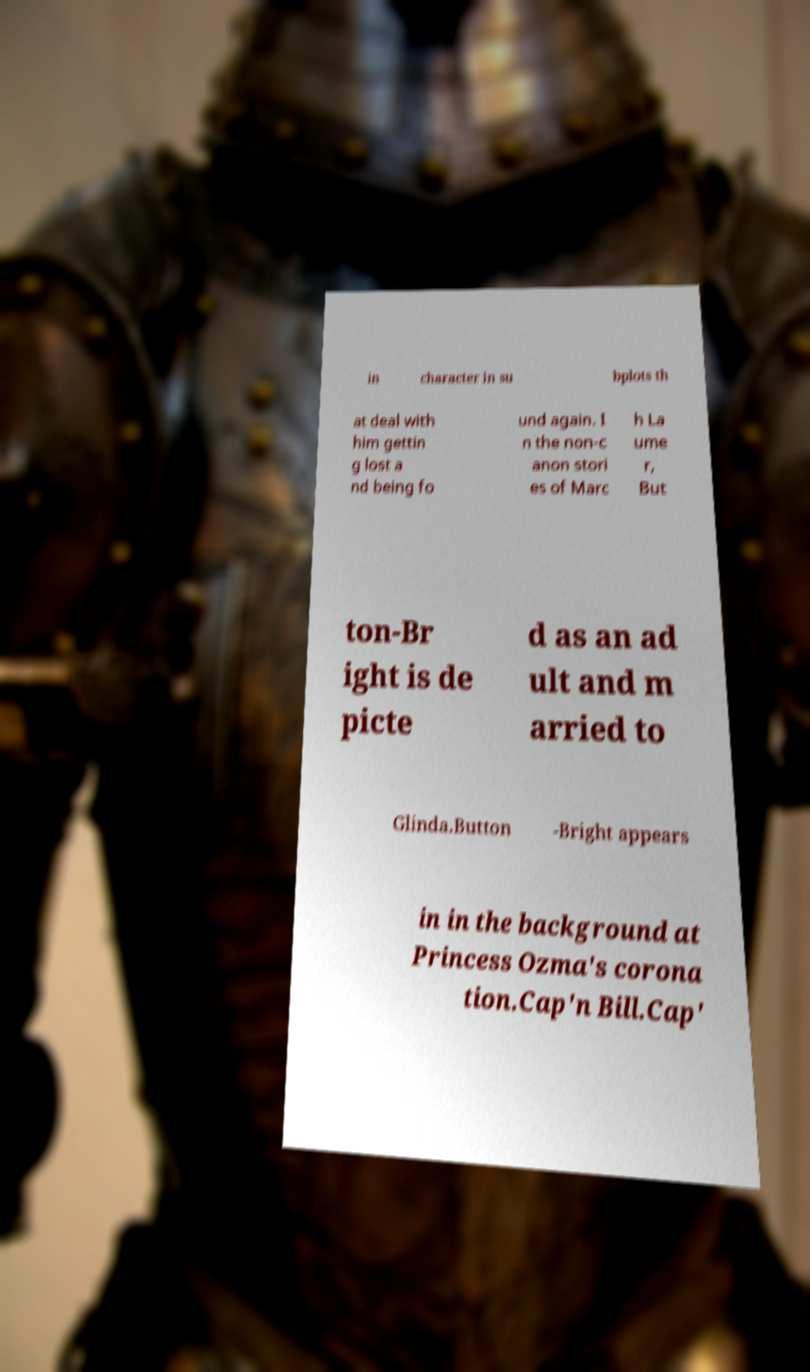For documentation purposes, I need the text within this image transcribed. Could you provide that? in character in su bplots th at deal with him gettin g lost a nd being fo und again. I n the non-c anon stori es of Marc h La ume r, But ton-Br ight is de picte d as an ad ult and m arried to Glinda.Button -Bright appears in in the background at Princess Ozma's corona tion.Cap'n Bill.Cap' 